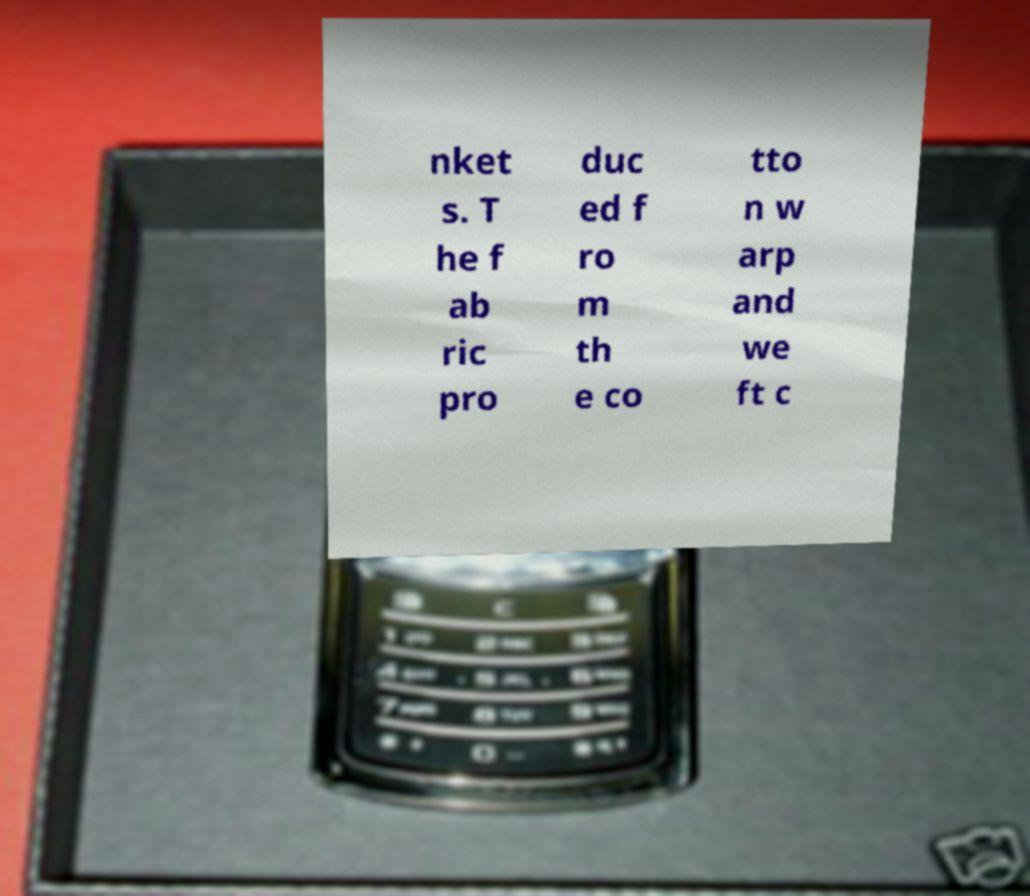Please read and relay the text visible in this image. What does it say? nket s. T he f ab ric pro duc ed f ro m th e co tto n w arp and we ft c 